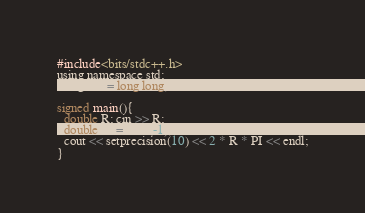Convert code to text. <code><loc_0><loc_0><loc_500><loc_500><_C_>#include<bits/stdc++.h>
using namespace std;
using lint = long long;

signed main(){
  double R; cin >> R;
  double PI = acos(-1);
  cout << setprecision(10) << 2 * R * PI << endl;
}</code> 